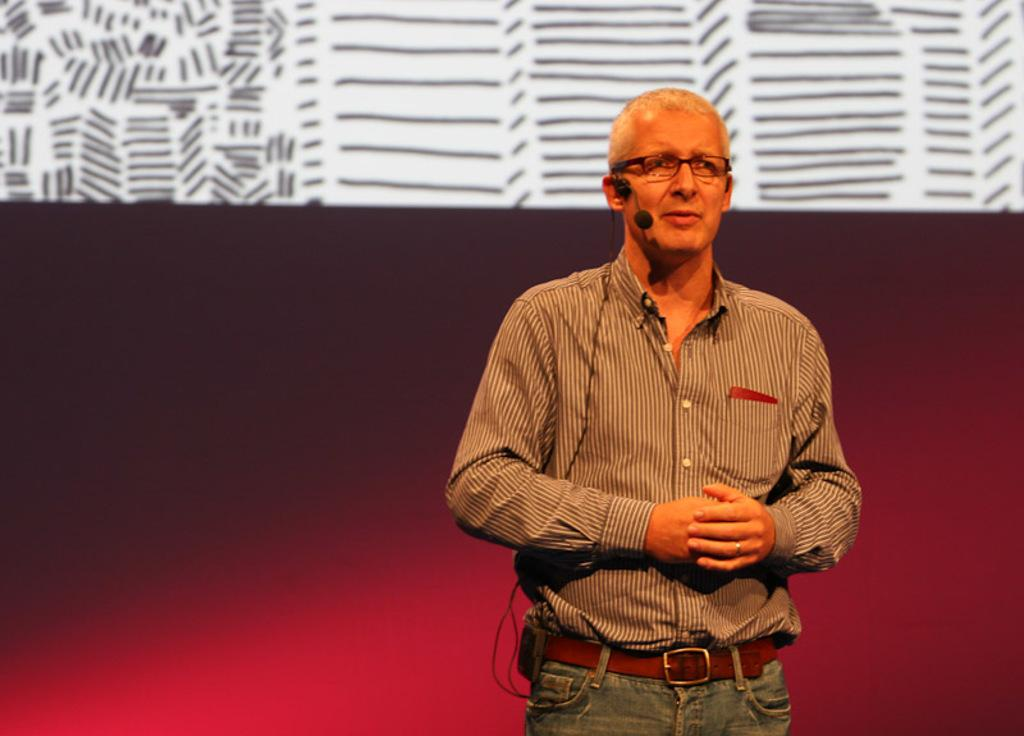What is the main subject of the image? There is a person in the image. What is the person wearing in the image? The person is wearing a head microphone. What can be seen behind the person in the image? There is a wall visible behind the person. What type of paste is being used by the person in the image? There is no paste visible or mentioned in the image. 